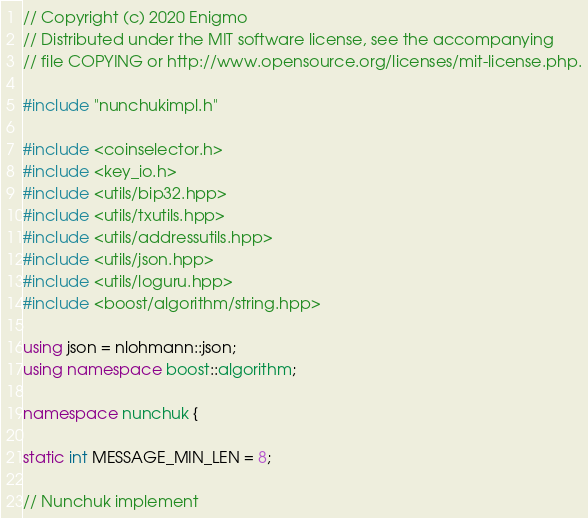<code> <loc_0><loc_0><loc_500><loc_500><_C++_>// Copyright (c) 2020 Enigmo
// Distributed under the MIT software license, see the accompanying
// file COPYING or http://www.opensource.org/licenses/mit-license.php.

#include "nunchukimpl.h"

#include <coinselector.h>
#include <key_io.h>
#include <utils/bip32.hpp>
#include <utils/txutils.hpp>
#include <utils/addressutils.hpp>
#include <utils/json.hpp>
#include <utils/loguru.hpp>
#include <boost/algorithm/string.hpp>

using json = nlohmann::json;
using namespace boost::algorithm;

namespace nunchuk {

static int MESSAGE_MIN_LEN = 8;

// Nunchuk implement</code> 